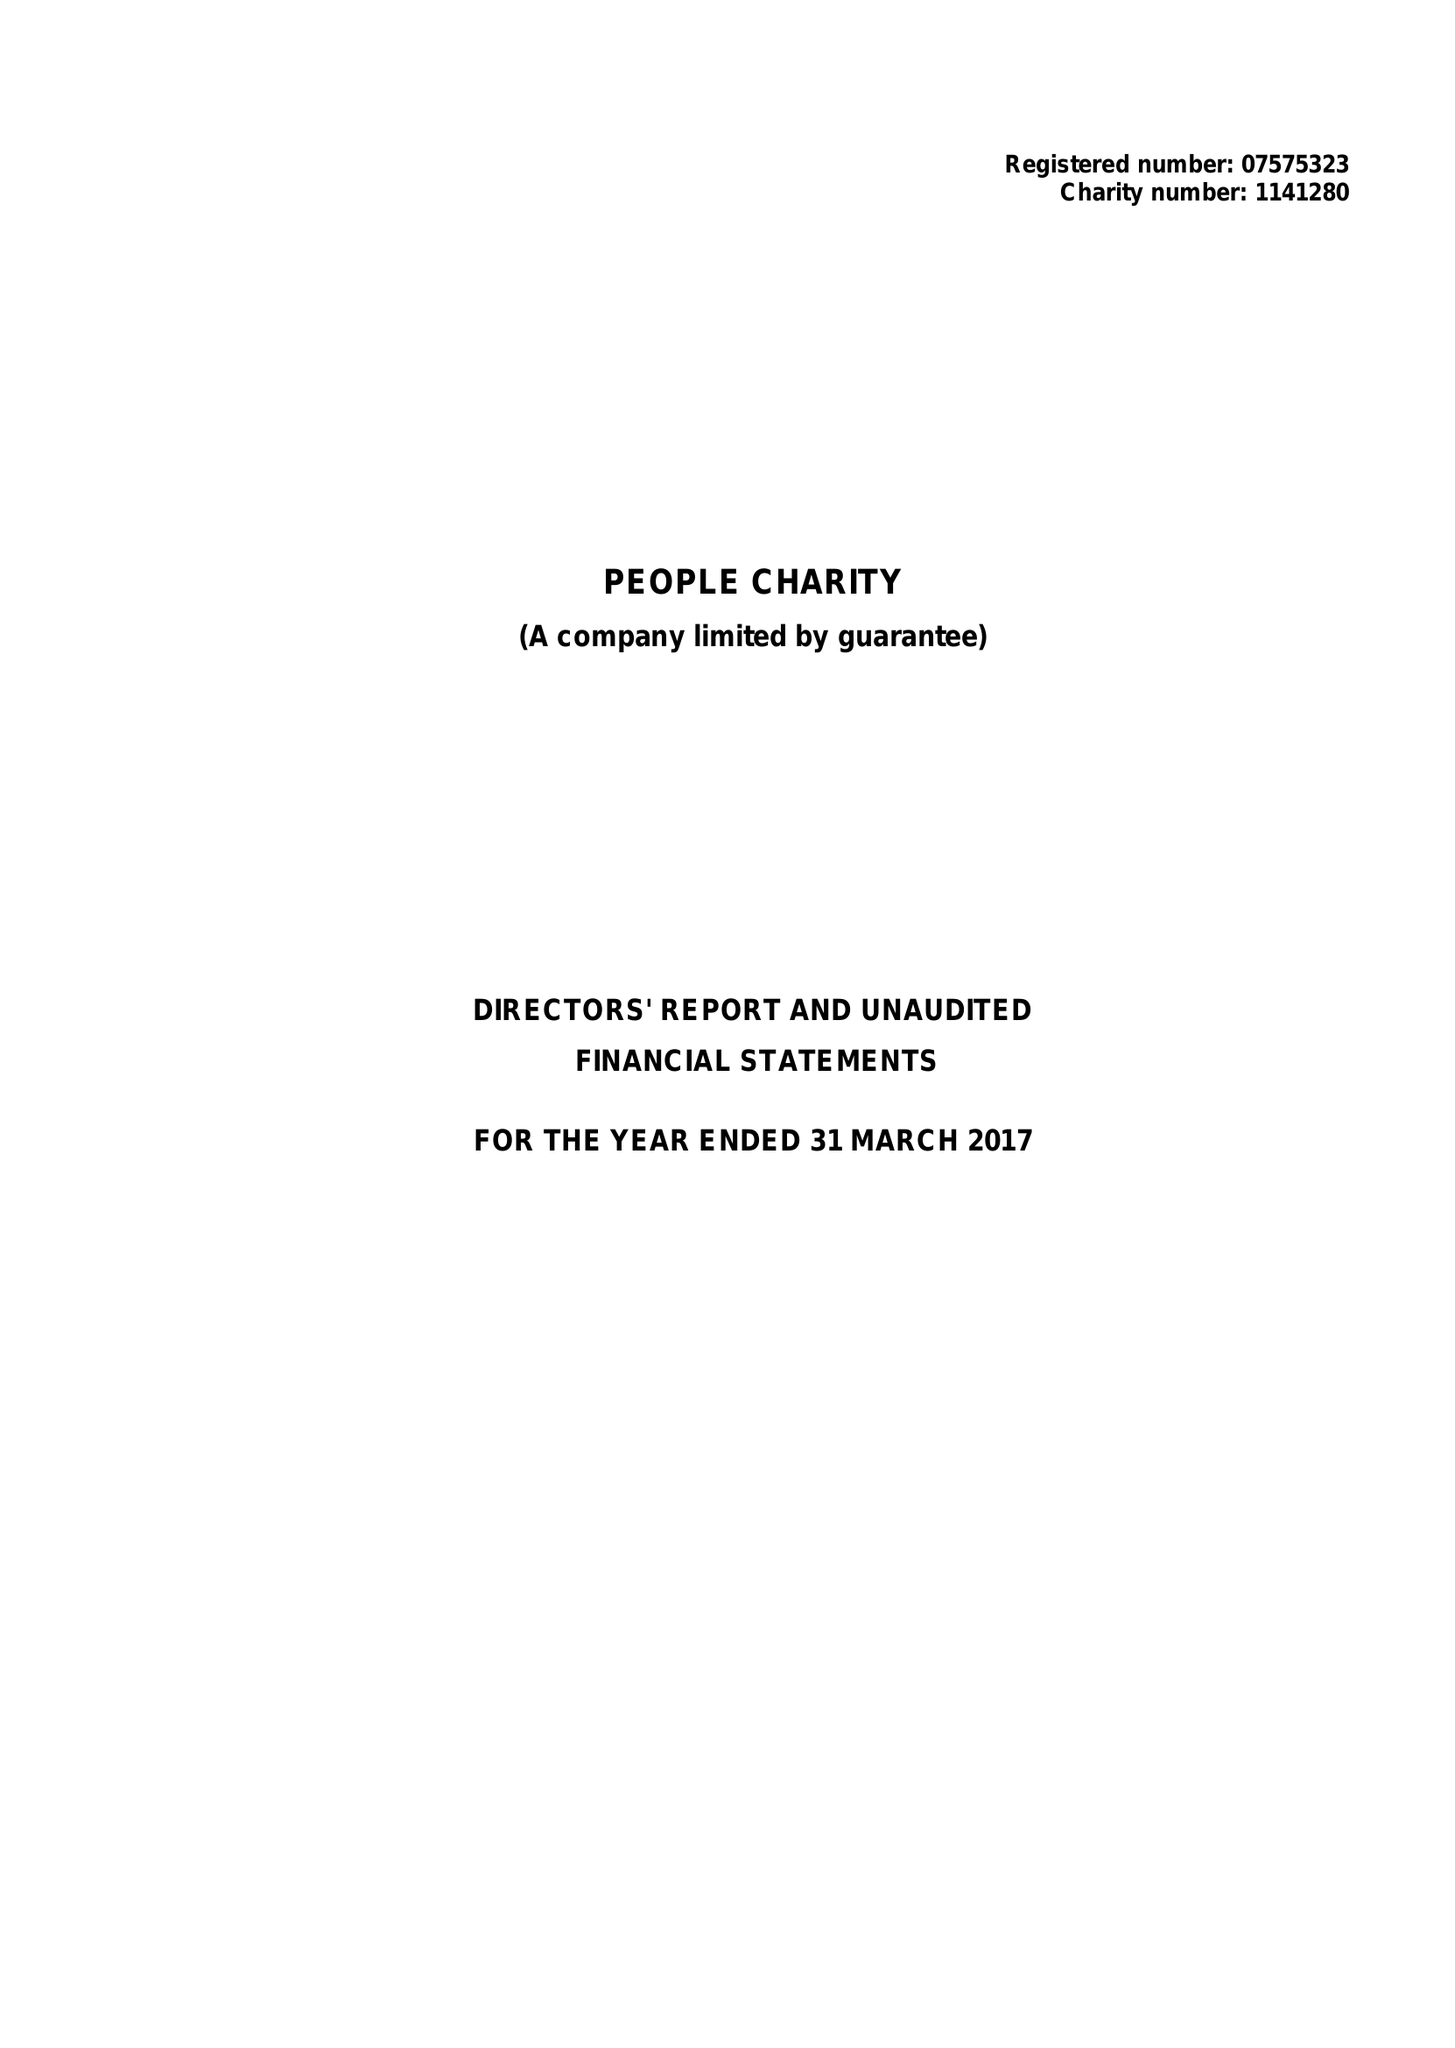What is the value for the income_annually_in_british_pounds?
Answer the question using a single word or phrase. 34561.00 